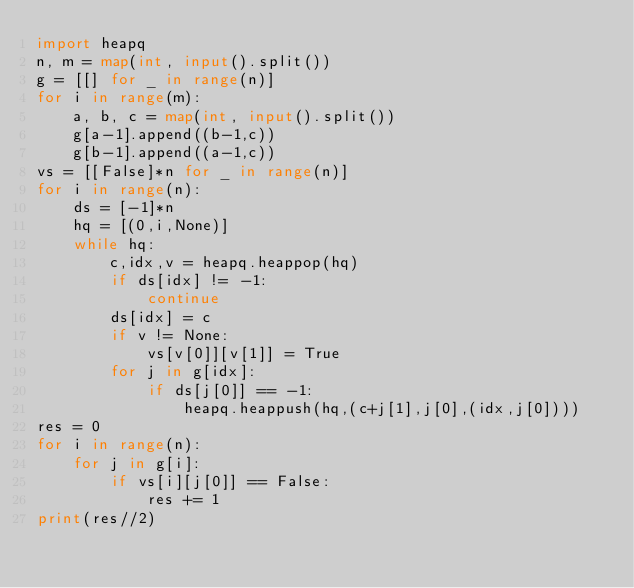Convert code to text. <code><loc_0><loc_0><loc_500><loc_500><_Python_>import heapq
n, m = map(int, input().split())
g = [[] for _ in range(n)]
for i in range(m):
    a, b, c = map(int, input().split())
    g[a-1].append((b-1,c))
    g[b-1].append((a-1,c))
vs = [[False]*n for _ in range(n)]
for i in range(n):
    ds = [-1]*n
    hq = [(0,i,None)]
    while hq:
        c,idx,v = heapq.heappop(hq)
        if ds[idx] != -1:
            continue
        ds[idx] = c
        if v != None:
            vs[v[0]][v[1]] = True
        for j in g[idx]:
            if ds[j[0]] == -1:
                heapq.heappush(hq,(c+j[1],j[0],(idx,j[0])))
res = 0
for i in range(n):
    for j in g[i]:
        if vs[i][j[0]] == False:
            res += 1
print(res//2)</code> 